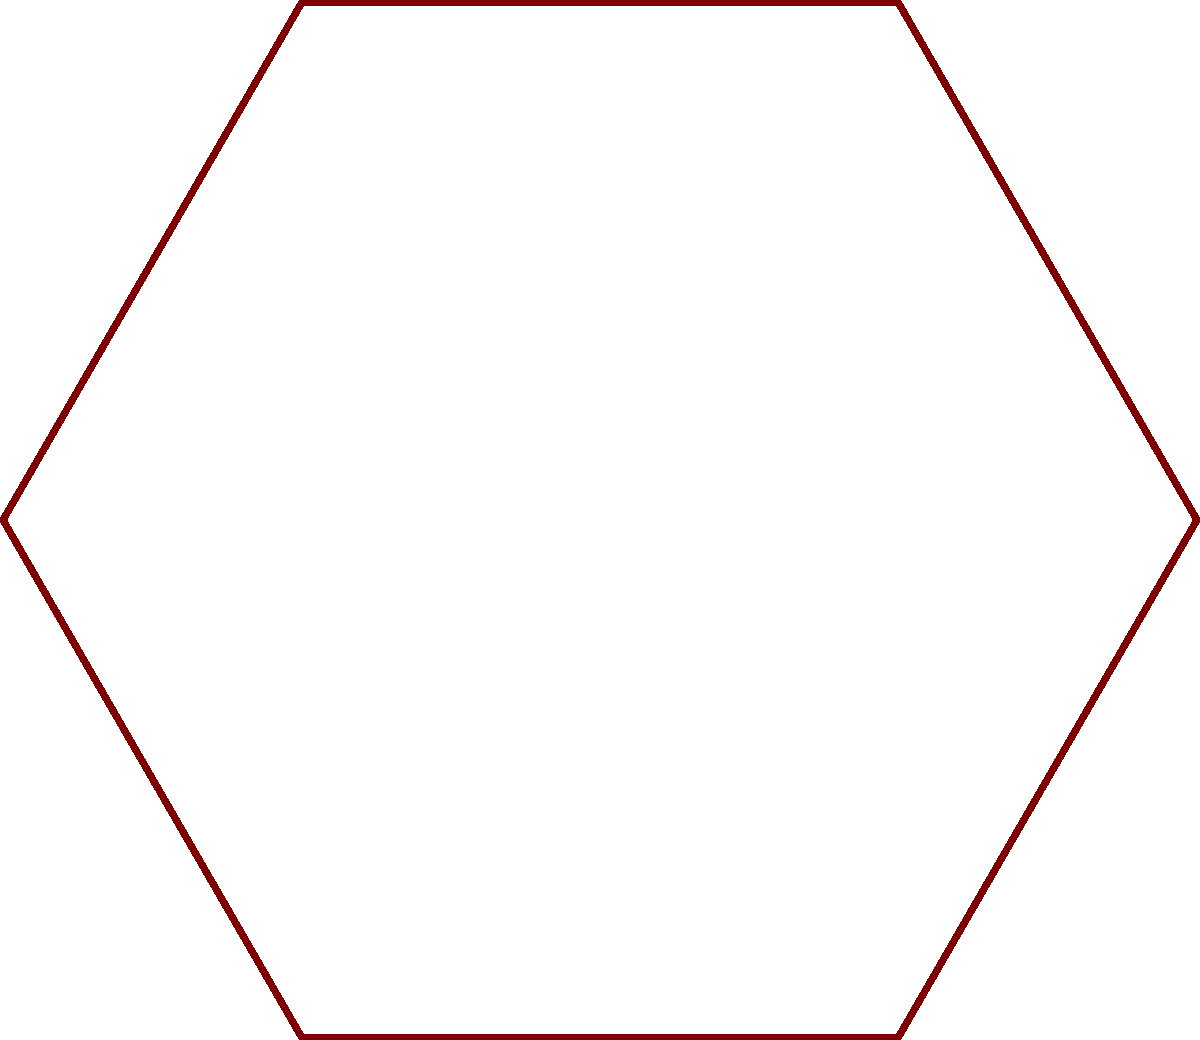For your country-themed wedding barn dance reception, you're creating a seating chart with 5 round tables. Each table seats 8 guests. The dance floor is centrally located, and you want to ensure a mix of families at each table. If you have 36 guests from the bride's side and 32 from the groom's side, what is the minimum number of tables that will have an uneven distribution of guests from each side? Let's approach this step-by-step:

1. Total number of guests:
   Bride's side: 36
   Groom's side: 32
   Total: 36 + 32 = 68 guests

2. Number of tables: 5

3. Guests per table: 8

4. Total seating capacity: 5 * 8 = 40 seats

5. To distribute guests evenly, we'd ideally have 4 guests from each side at each table:
   4 (bride's side) + 4 (groom's side) = 8 guests per table

6. However, we have more guests than seats, so we need to calculate the difference:
   68 (total guests) - 40 (total seats) = 28 extra guests

7. These extra guests need to be distributed among the tables. Let's see how many from each side:
   Bride's side extras: 36 - (5 * 4) = 16
   Groom's side extras: 32 - (5 * 4) = 12

8. The difference in extras: 16 - 12 = 4

9. This means that no matter how we distribute the guests, there will always be 4 more guests from the bride's side than the groom's side spread across the tables.

10. The minimum number of tables that will have an uneven distribution is 4, as we need to place these 4 extra guests from the bride's side.

Therefore, at least 4 out of the 5 tables will have an uneven distribution of guests from each side.
Answer: 4 tables 